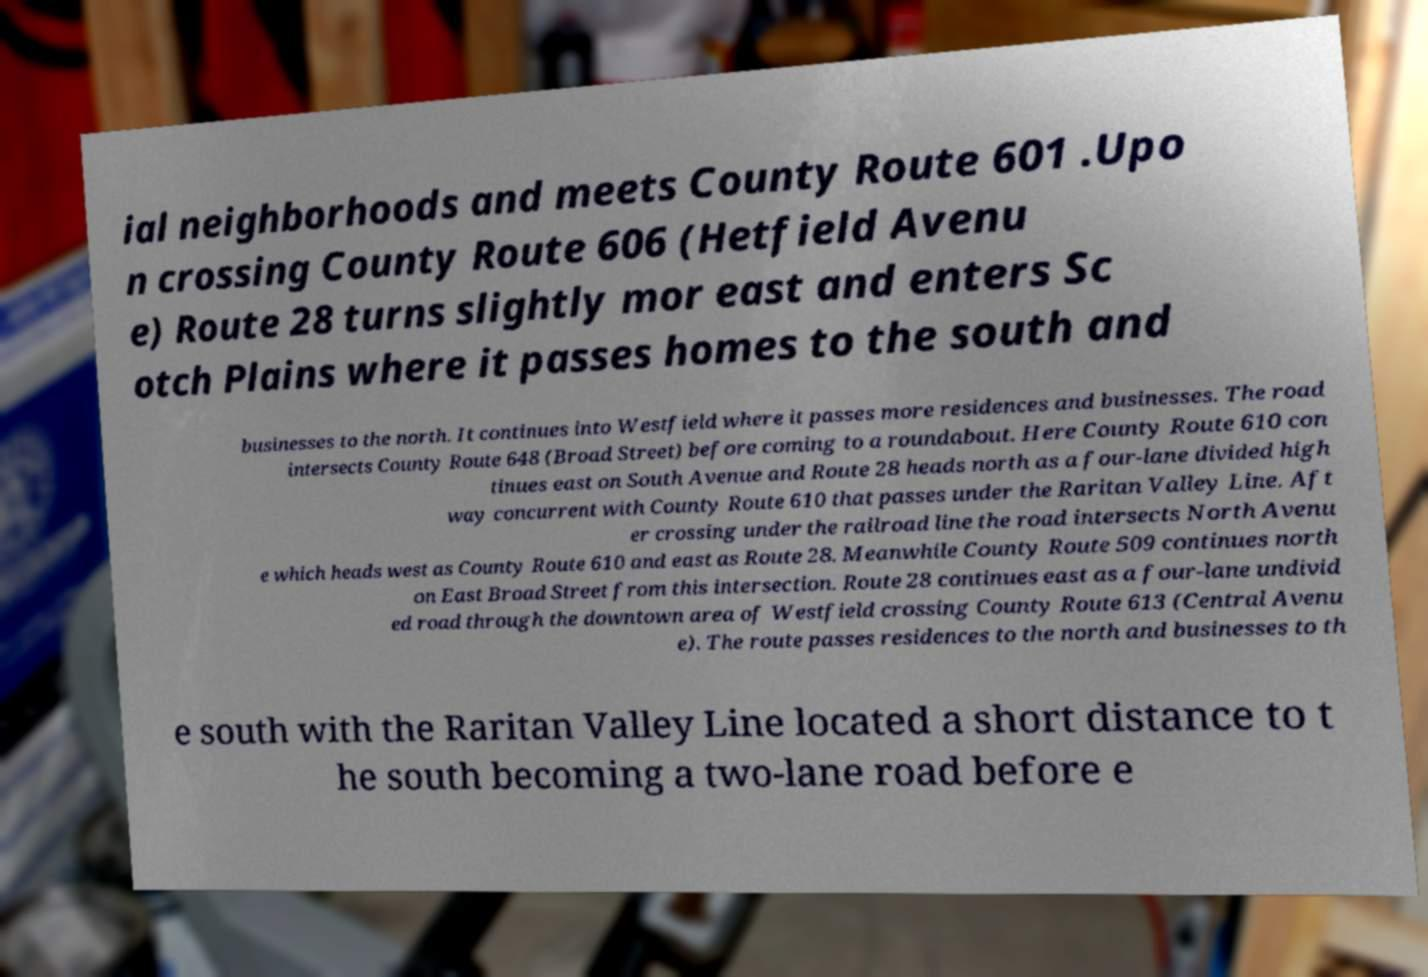Please read and relay the text visible in this image. What does it say? ial neighborhoods and meets County Route 601 .Upo n crossing County Route 606 (Hetfield Avenu e) Route 28 turns slightly mor east and enters Sc otch Plains where it passes homes to the south and businesses to the north. It continues into Westfield where it passes more residences and businesses. The road intersects County Route 648 (Broad Street) before coming to a roundabout. Here County Route 610 con tinues east on South Avenue and Route 28 heads north as a four-lane divided high way concurrent with County Route 610 that passes under the Raritan Valley Line. Aft er crossing under the railroad line the road intersects North Avenu e which heads west as County Route 610 and east as Route 28. Meanwhile County Route 509 continues north on East Broad Street from this intersection. Route 28 continues east as a four-lane undivid ed road through the downtown area of Westfield crossing County Route 613 (Central Avenu e). The route passes residences to the north and businesses to th e south with the Raritan Valley Line located a short distance to t he south becoming a two-lane road before e 